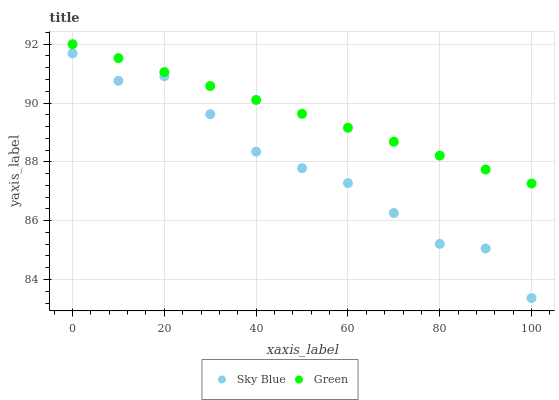Does Sky Blue have the minimum area under the curve?
Answer yes or no. Yes. Does Green have the maximum area under the curve?
Answer yes or no. Yes. Does Green have the minimum area under the curve?
Answer yes or no. No. Is Green the smoothest?
Answer yes or no. Yes. Is Sky Blue the roughest?
Answer yes or no. Yes. Is Green the roughest?
Answer yes or no. No. Does Sky Blue have the lowest value?
Answer yes or no. Yes. Does Green have the lowest value?
Answer yes or no. No. Does Green have the highest value?
Answer yes or no. Yes. Is Sky Blue less than Green?
Answer yes or no. Yes. Is Green greater than Sky Blue?
Answer yes or no. Yes. Does Sky Blue intersect Green?
Answer yes or no. No. 